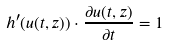<formula> <loc_0><loc_0><loc_500><loc_500>h ^ { \prime } ( u ( t , z ) ) \cdot \frac { \partial u ( t , z ) } { \partial t } = 1</formula> 